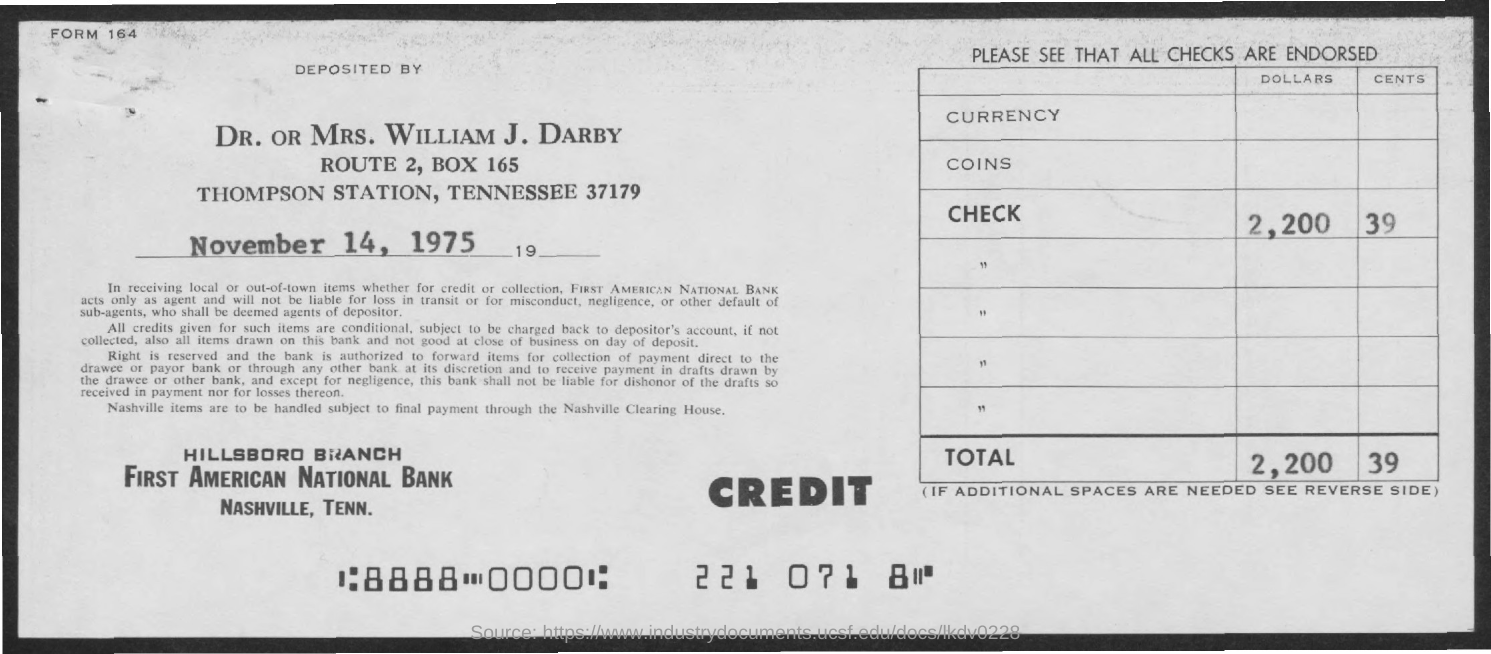What is the date?
Your answer should be very brief. November 14, 1975. 